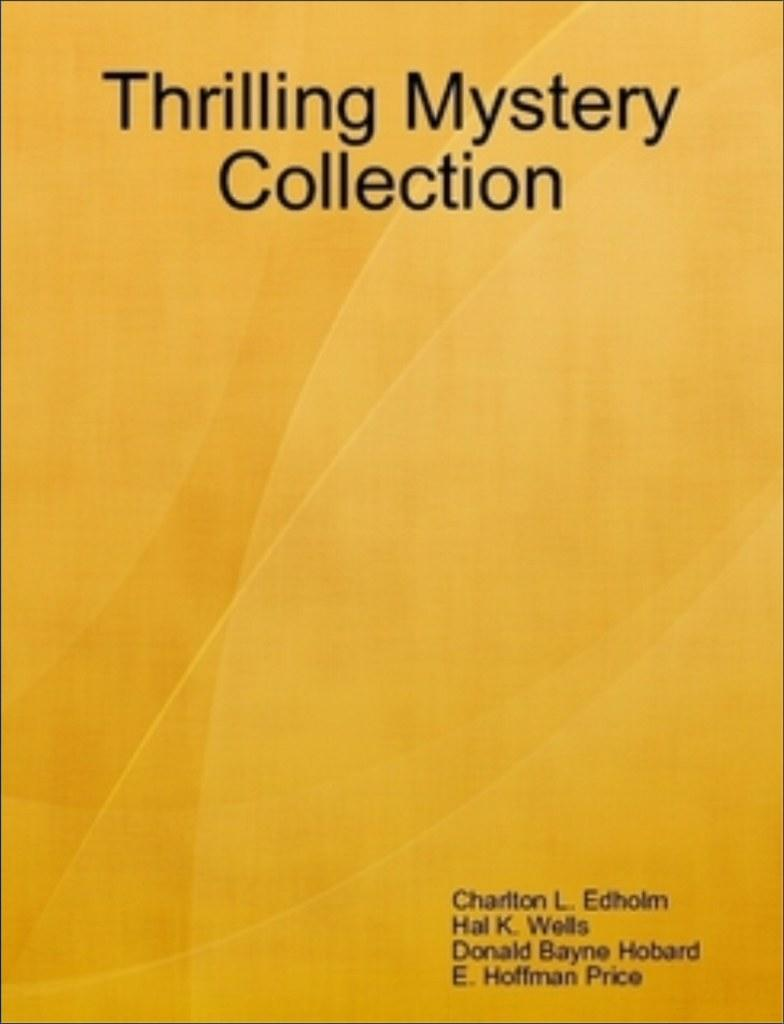<image>
Offer a succinct explanation of the picture presented. the title of the book is 'Thrilling Mystery Collection' 